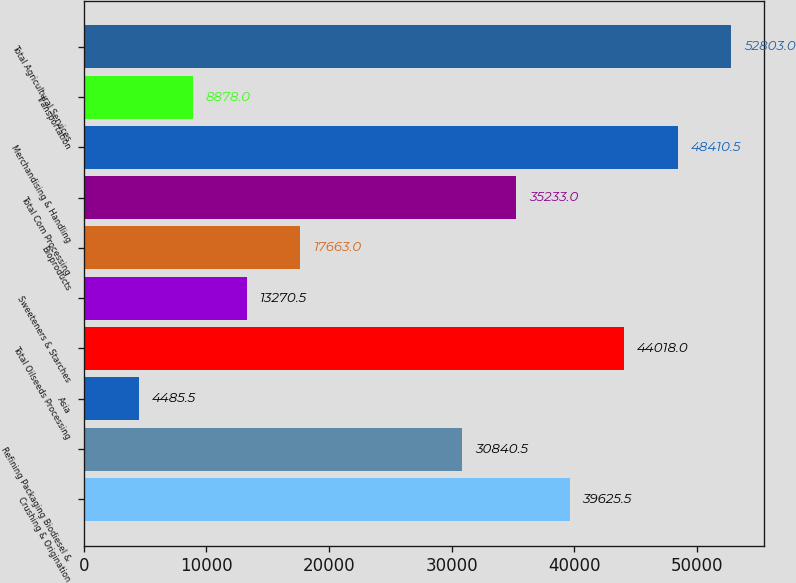Convert chart to OTSL. <chart><loc_0><loc_0><loc_500><loc_500><bar_chart><fcel>Crushing & Origination<fcel>Refining Packaging Biodiesel &<fcel>Asia<fcel>Total Oilseeds Processing<fcel>Sweeteners & Starches<fcel>Bioproducts<fcel>Total Corn Processing<fcel>Merchandising & Handling<fcel>Transportation<fcel>Total Agricultural Services<nl><fcel>39625.5<fcel>30840.5<fcel>4485.5<fcel>44018<fcel>13270.5<fcel>17663<fcel>35233<fcel>48410.5<fcel>8878<fcel>52803<nl></chart> 